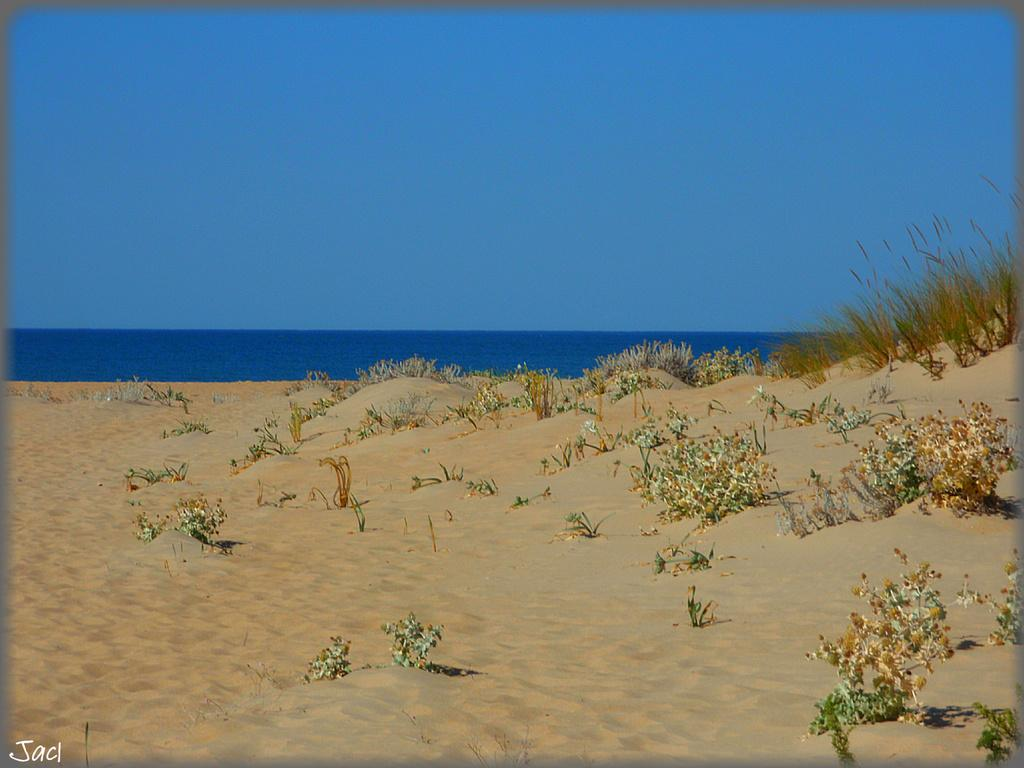What celestial bodies can be seen in the image? There are planets visible in the image. What natural element is present in the image? There is water visible in the image. What can be seen in the background of the image? The sky is visible in the background of the image. What type of net is being used to catch the planets in the image? There is no net present in the image, and the planets are not being caught. 